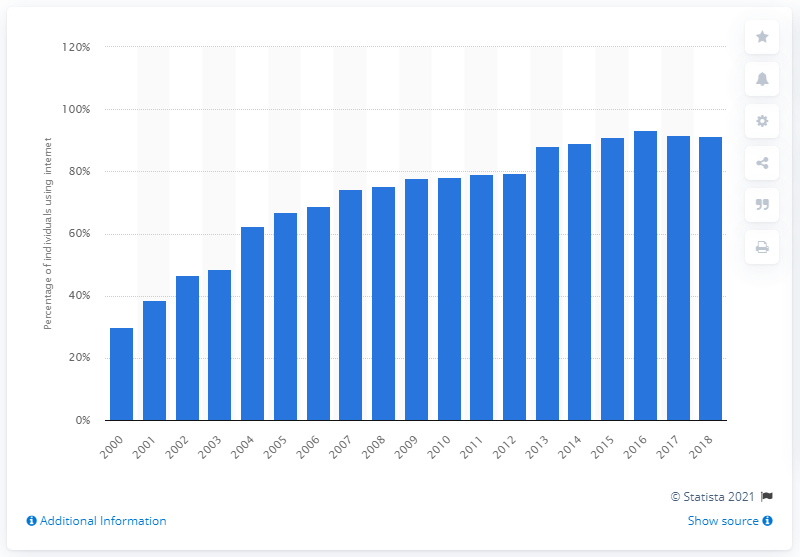Identify some key points in this picture. In 2015, the internet penetration rate in Japan was 89.11%. 